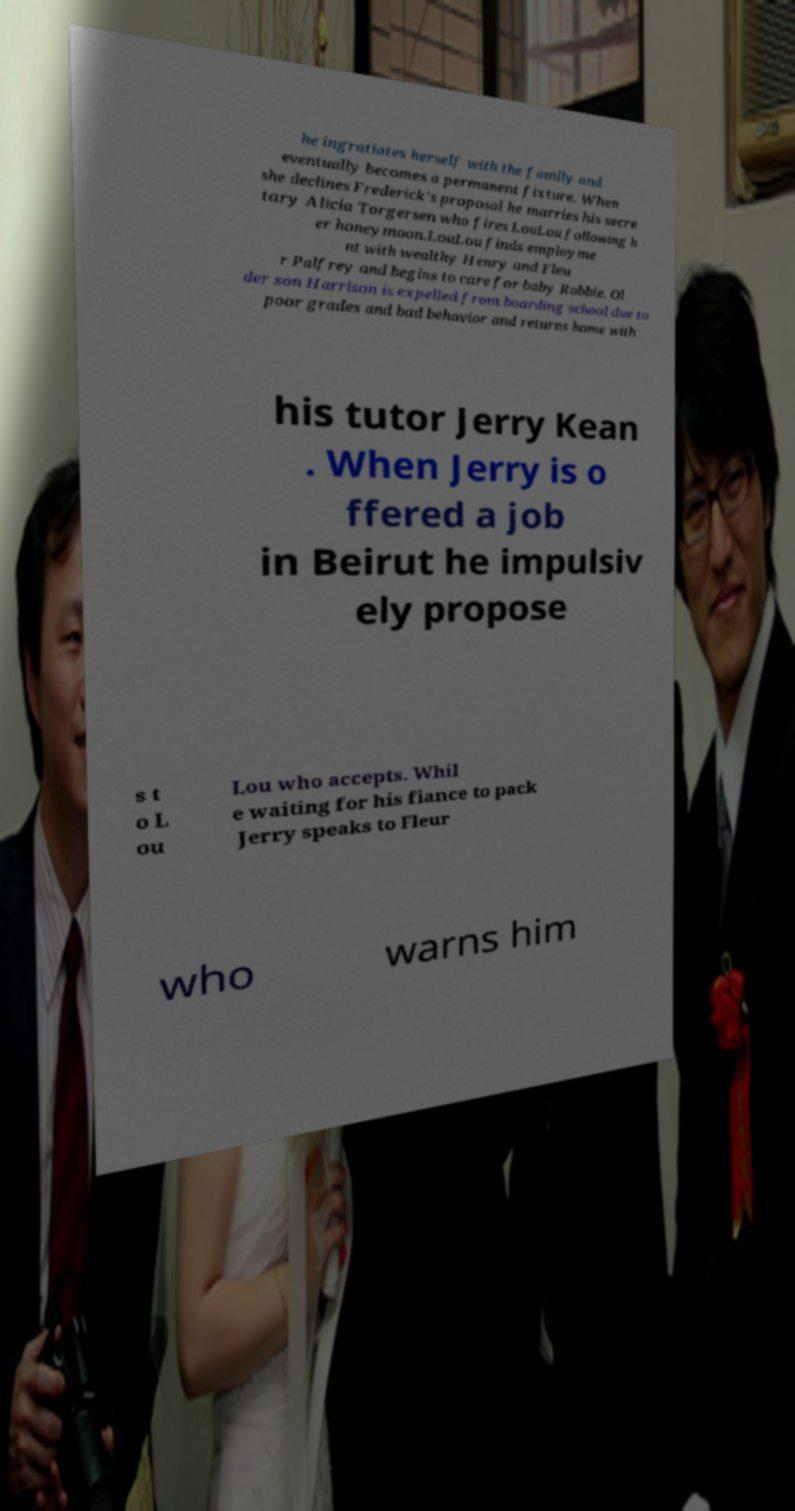I need the written content from this picture converted into text. Can you do that? he ingratiates herself with the family and eventually becomes a permanent fixture. When she declines Frederick's proposal he marries his secre tary Alicia Torgersen who fires LouLou following h er honeymoon.LouLou finds employme nt with wealthy Henry and Fleu r Palfrey and begins to care for baby Robbie. Ol der son Harrison is expelled from boarding school due to poor grades and bad behavior and returns home with his tutor Jerry Kean . When Jerry is o ffered a job in Beirut he impulsiv ely propose s t o L ou Lou who accepts. Whil e waiting for his fiance to pack Jerry speaks to Fleur who warns him 